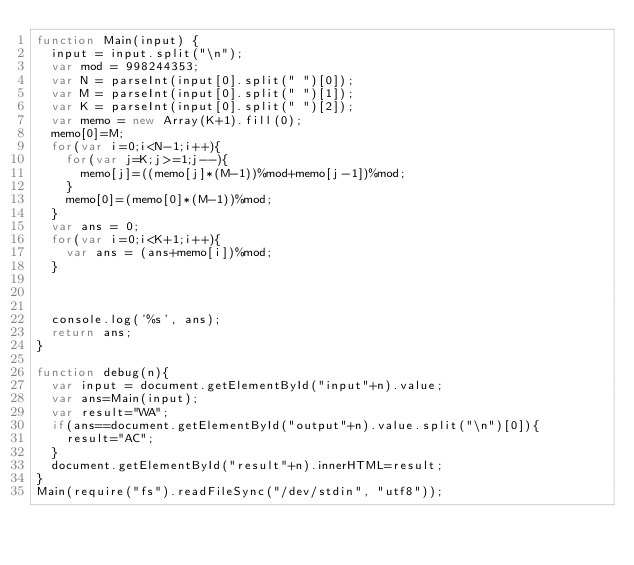<code> <loc_0><loc_0><loc_500><loc_500><_JavaScript_>function Main(input) {
  input = input.split("\n");
  var mod = 998244353;
  var N = parseInt(input[0].split(" ")[0]);
  var M = parseInt(input[0].split(" ")[1]);
  var K = parseInt(input[0].split(" ")[2]);
  var memo = new Array(K+1).fill(0);
  memo[0]=M;
  for(var i=0;i<N-1;i++){
    for(var j=K;j>=1;j--){
      memo[j]=((memo[j]*(M-1))%mod+memo[j-1])%mod;
    }
    memo[0]=(memo[0]*(M-1))%mod;
  }
  var ans = 0;
  for(var i=0;i<K+1;i++){
    var ans = (ans+memo[i])%mod;
  }



  console.log('%s', ans);
  return ans;
}

function debug(n){
  var input = document.getElementById("input"+n).value;
  var ans=Main(input);
  var result="WA";
  if(ans==document.getElementById("output"+n).value.split("\n")[0]){
    result="AC";
  }
  document.getElementById("result"+n).innerHTML=result;
}
Main(require("fs").readFileSync("/dev/stdin", "utf8"));</code> 